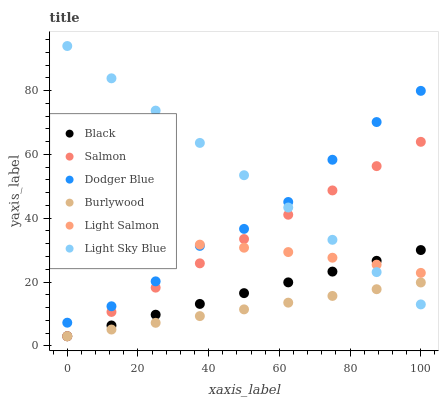Does Burlywood have the minimum area under the curve?
Answer yes or no. Yes. Does Light Sky Blue have the maximum area under the curve?
Answer yes or no. Yes. Does Salmon have the minimum area under the curve?
Answer yes or no. No. Does Salmon have the maximum area under the curve?
Answer yes or no. No. Is Black the smoothest?
Answer yes or no. Yes. Is Dodger Blue the roughest?
Answer yes or no. Yes. Is Burlywood the smoothest?
Answer yes or no. No. Is Burlywood the roughest?
Answer yes or no. No. Does Burlywood have the lowest value?
Answer yes or no. Yes. Does Light Sky Blue have the lowest value?
Answer yes or no. No. Does Light Sky Blue have the highest value?
Answer yes or no. Yes. Does Salmon have the highest value?
Answer yes or no. No. Is Salmon less than Dodger Blue?
Answer yes or no. Yes. Is Dodger Blue greater than Burlywood?
Answer yes or no. Yes. Does Black intersect Salmon?
Answer yes or no. Yes. Is Black less than Salmon?
Answer yes or no. No. Is Black greater than Salmon?
Answer yes or no. No. Does Salmon intersect Dodger Blue?
Answer yes or no. No. 